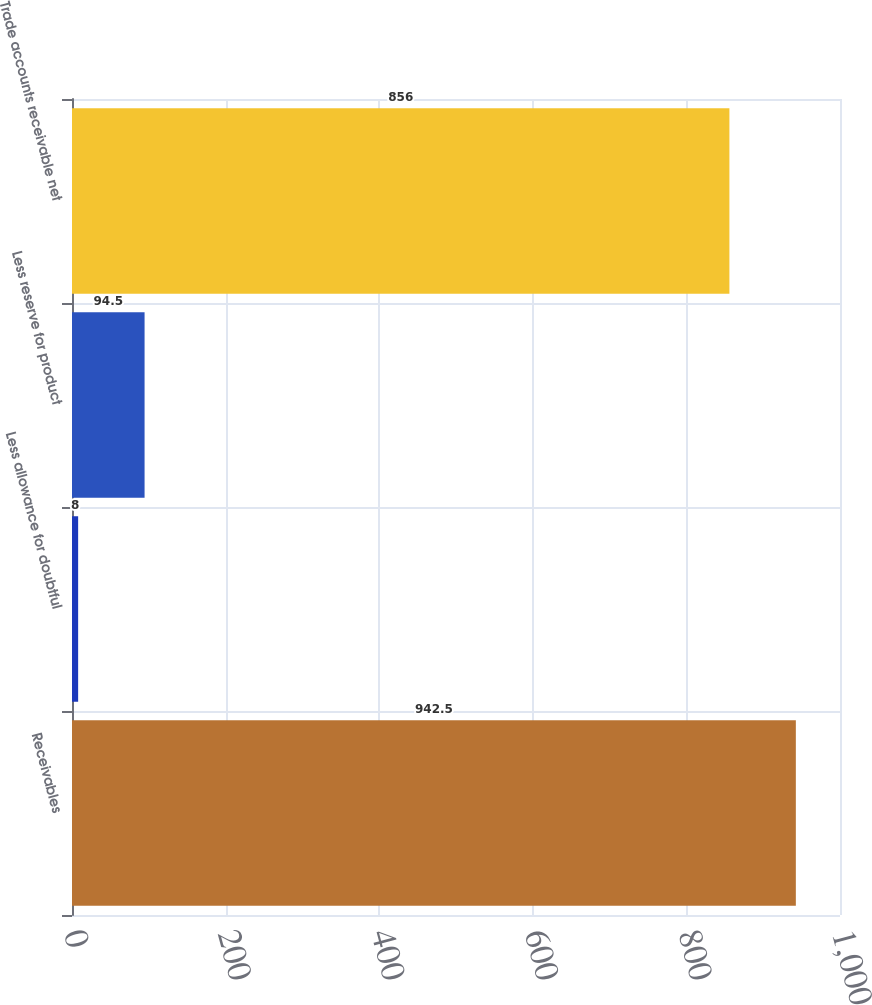<chart> <loc_0><loc_0><loc_500><loc_500><bar_chart><fcel>Receivables<fcel>Less allowance for doubtful<fcel>Less reserve for product<fcel>Trade accounts receivable net<nl><fcel>942.5<fcel>8<fcel>94.5<fcel>856<nl></chart> 